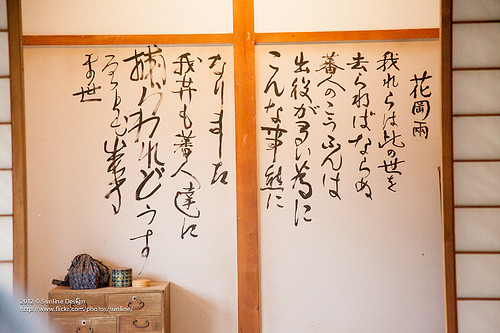<image>
Can you confirm if the writing is on the wood? No. The writing is not positioned on the wood. They may be near each other, but the writing is not supported by or resting on top of the wood. 